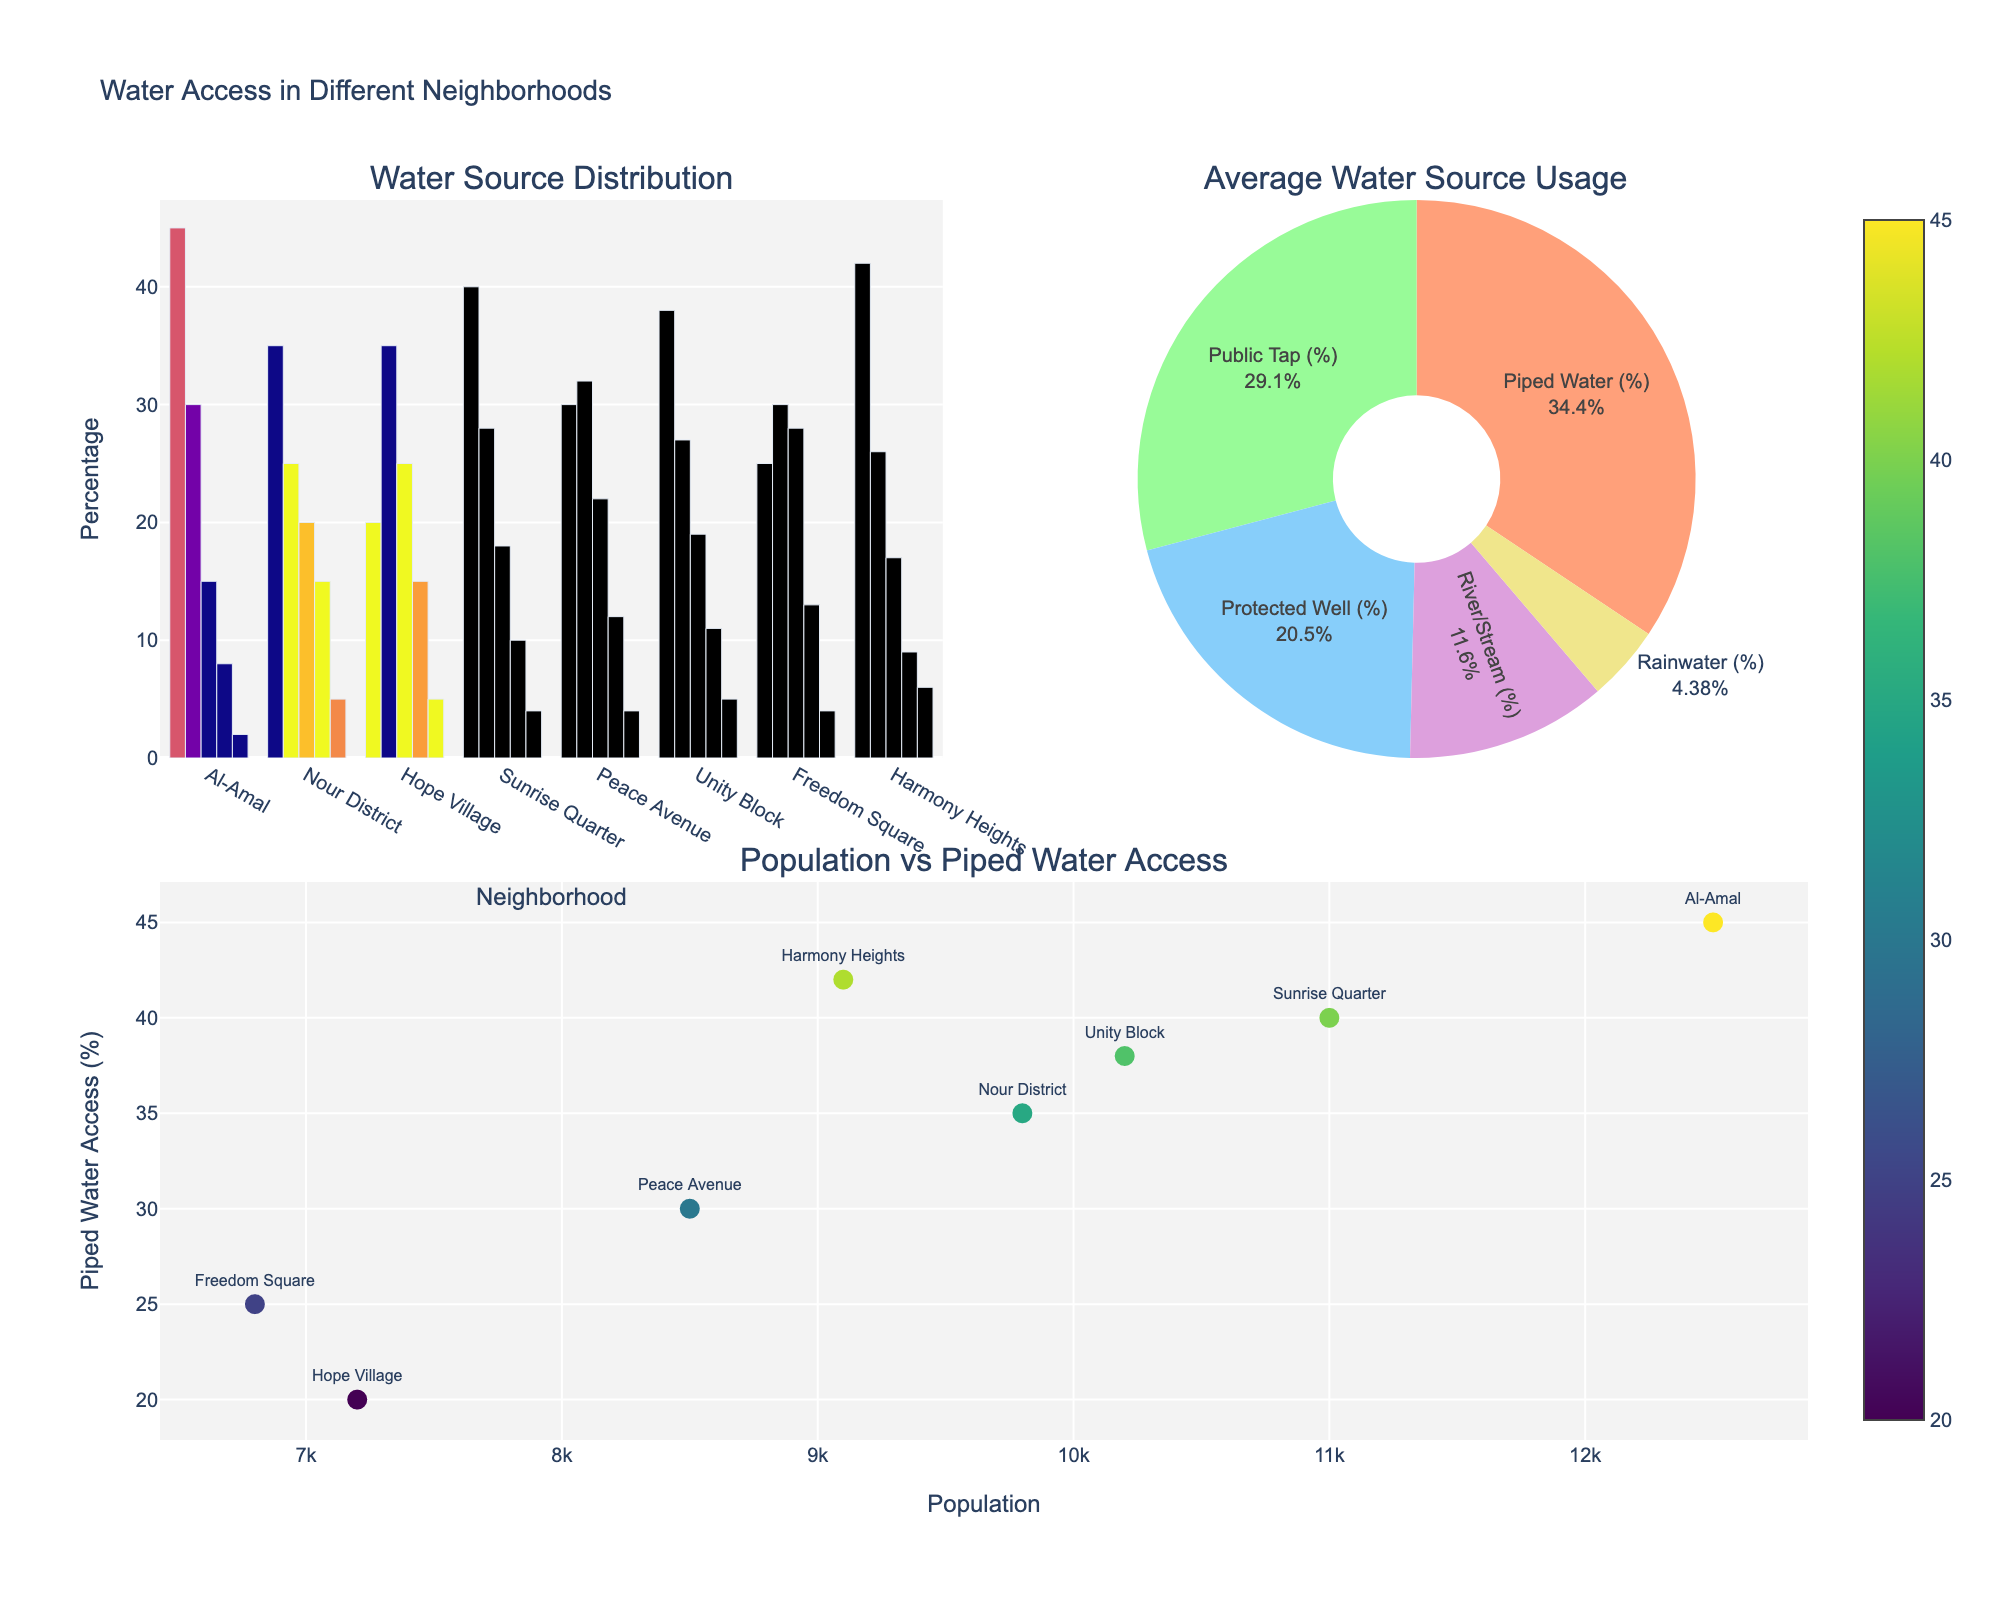How many neighborhoods are shown in the bar chart? Count the number of distinct neighborhoods listed on the x-axis of the bar chart.
Answer: 8 What is the title of this figure? Read the main title displayed above the plots.
Answer: Water Access in Different Neighborhoods Which neighborhood has the highest piped water access percentage? Identify the neighborhood with the tallest bar for the "Piped Water (%)" category in the bar chart.
Answer: Al-Amal How does the water source distribution compare between Al-Amal and Nour District in terms of "Piped Water (%)"? Locate the bars representing "Piped Water (%)" for both Al-Amal and Nour District and compare their heights.
Answer: Al-Amal > Nour District What's the average usage percentage of public tap water across all neighborhoods? Refer to the pie chart, find the public tap water section, and check its displayed percentage.
Answer: 29.1% Which neighborhood has the smallest population but relatively high usage of protected wells? Identify the neighborhood with the smallest population from the scatter plot and then cross-reference its usage of protected wells from the bar chart.
Answer: Freedom Square Is there a trend between population size and piped water access percentages? Observe the scatter plot to see if there is a noticeable pattern or correlation between the x-axis (population size) and y-axis (piped water access percentages).
Answer: No clear trend Which water source type is the least used on average? Look at the pie chart and identify the segment with the smallest percentage.
Answer: Rainwater What is the combined percentage of River/Stream and Rainwater usage in Peace Avenue? Find the percentages of River/Stream and Rainwater bars in Peace Avenue and sum them up (12% + 4%).
Answer: 16% Which water source type has similar average usage percentages in Sunrise Quarter and Unity Block? Compare the bars for each water source in both neighborhoods and find the source types with near-identical heights.
Answer: Public Tap 